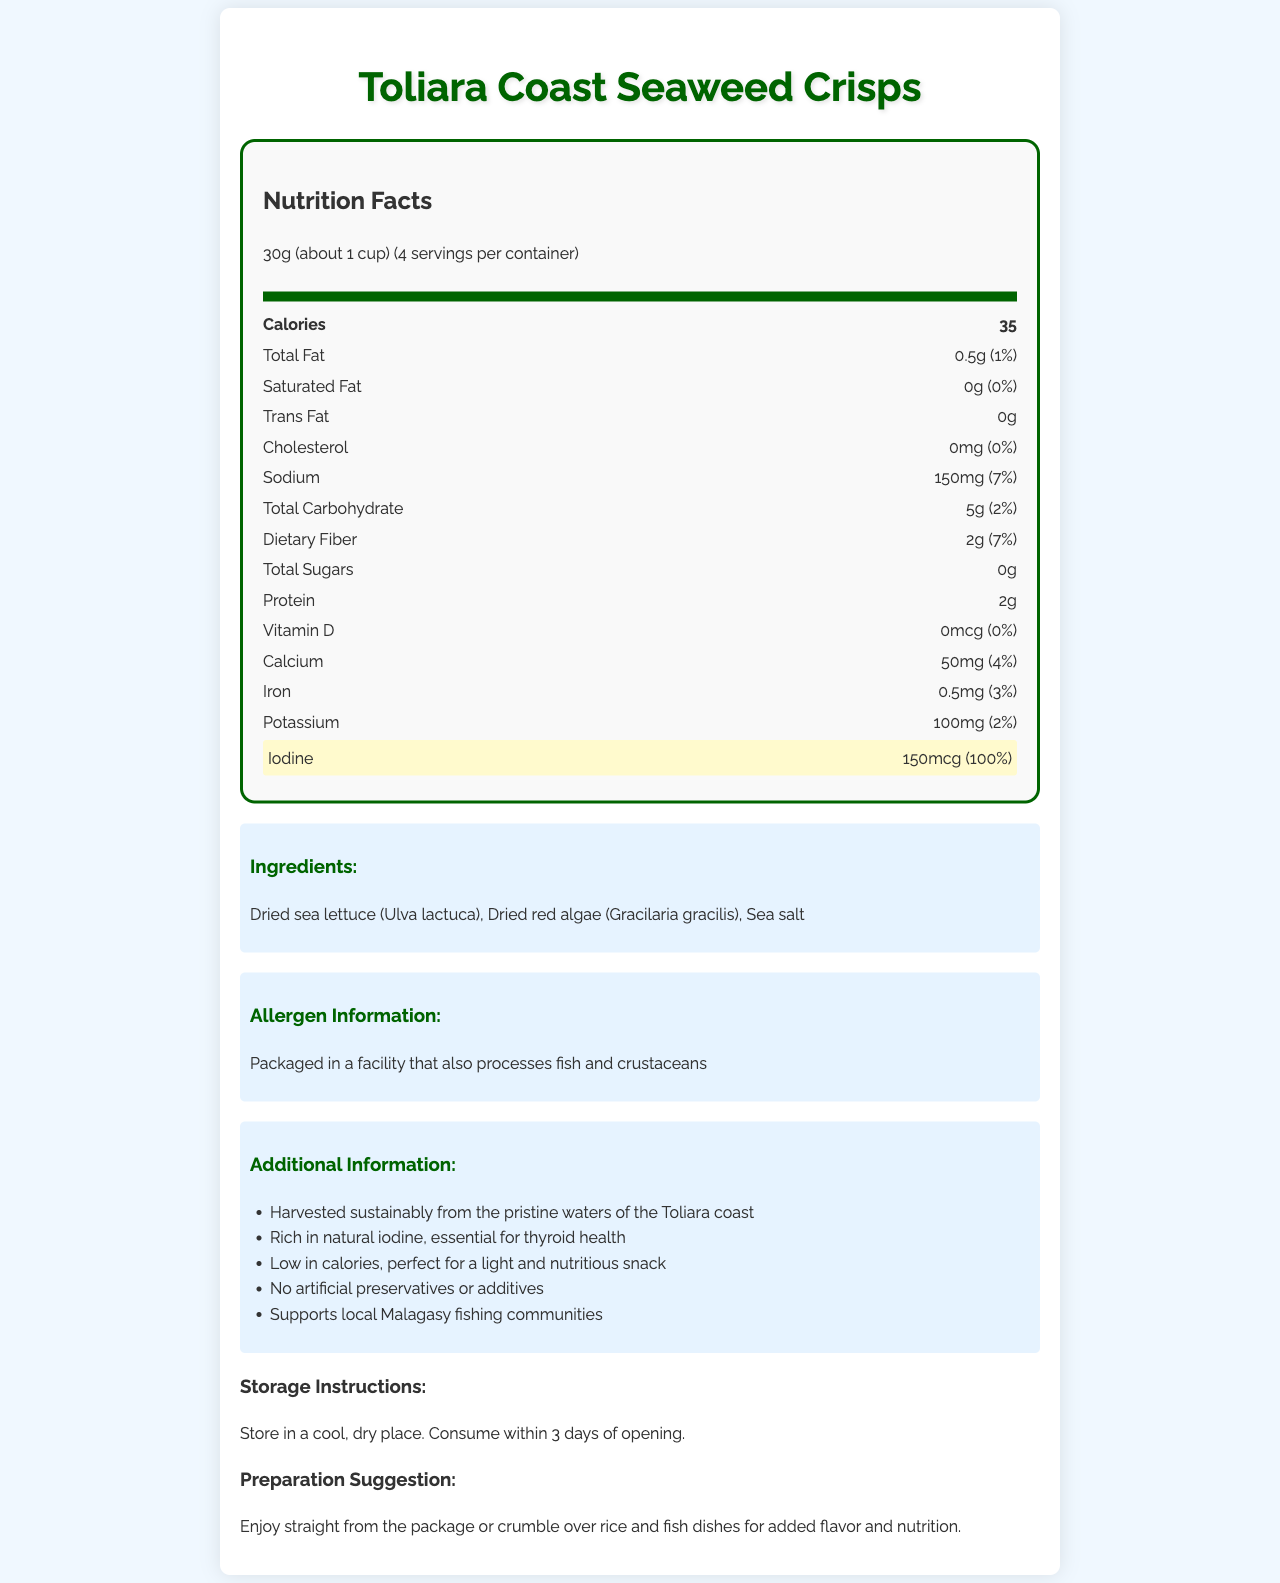what is the product name? The product name is displayed at the top and in the title of the document.
Answer: Toliara Coast Seaweed Crisps what is the serving size? The serving size is listed under the Nutrition Facts heading.
Answer: 30g (about 1 cup) how many calories are in one serving? The calorie count per serving is highlighted and located near the top of the Nutrition Facts section.
Answer: 35 how much iodine does one serving contain? The iodine content is specifically highlighted near the bottom of the Nutrition Facts section.
Answer: 150mcg what are the main ingredients in this seaweed snack? The ingredients are listed under the Ingredients section.
Answer: Dried sea lettuce (Ulva lactuca), Dried red algae (Gracilaria gracilis), Sea salt what is the percentage of daily value for calcium provided by one serving? The daily value percentage for calcium is listed in the Nutrition Facts.
Answer: 4% what is the total fat content per serving? The total fat content is displayed under the Nutrition Facts section, showing both the amount and the daily value percentage.
Answer: 0.5g (1% daily value) how much dietary fiber does the product contain per serving? The dietary fiber content is listed in the Nutrition Facts, with both the amount and the daily value percentage.
Answer: 2g (7% daily value) how much sodium is in one serving of the seaweed crisps? The sodium content per serving is listed in the Nutrition Facts.
Answer: 150mg (7% daily value) are there any artificial preservatives in this product? The additional information states that the product has no artificial preservatives or additives.
Answer: No does this product contain any cholesterol? The Nutrition Facts section lists cholesterol as 0mg (0% daily value).
Answer: No how many servings are in one container? The serving size information mentions that there are 4 servings per container.
Answer: 4 how much protein is in one serving? The amount of protein per serving is listed in the Nutrition Facts section.
Answer: 2g which mineral is highlighted for its high daily value in this product? A. Calcium B. Iron C. Iodine D. Potassium The iodine content is highlighted with a daily value percentage of 100%.
Answer: C. Iodine what percentage of the daily value of potassium does one serving provide? A. 1% B. 2% C. 3% D. 4% The daily value of potassium is listed as 100mg, which is 2% of the daily value.
Answer: B. 2% is the product suitable for someone with a shellfish allergy? The allergen information notes that the product is packaged in a facility that also processes fish and crustaceans, which could pose a risk.
Answer: No where is the seaweed for this product harvested? The additional information section states that the seaweed is harvested sustainably from the Toliara coast.
Answer: From the pristine waters of the Toliara coast can the preparation suggestion be used for other dishes besides rice and fish? Although the preparation suggestion mentions crumbling the seaweed over rice and fish dishes, it can be implied that the seaweed can be used for flavor and nutrition in other dishes as well.
Answer: Yes describe the entire document The document offers a comprehensive overview of the nutritional content, ingredients, and added benefits of the seaweed crisps, emphasizing its healthiness and local sourcing.
Answer: The document provides the Nutrition Facts label for Toliara Coast Seaweed Crisps, including information on serving size, calories, macronutrients, micronutrients, and ingredients. It highlights the iodine content and low calorie count. Additional details include allergen information, storage instructions, preparation suggestions, and a statement about supporting local Malagasy fishing communities. what is the source of the sea salt used in the crisps? The document does not specify the source of the sea salt used in the seaweed crisps.
Answer: Not enough information 